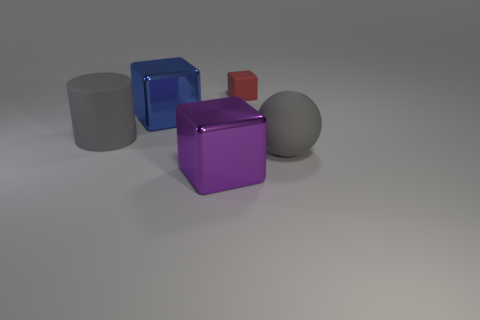Subtract all red blocks. How many blocks are left? 2 Add 4 gray rubber cylinders. How many objects exist? 9 Subtract all gray blocks. Subtract all gray balls. How many blocks are left? 3 Subtract all cubes. How many objects are left? 2 Add 5 gray matte cylinders. How many gray matte cylinders are left? 6 Add 4 tiny blue matte spheres. How many tiny blue matte spheres exist? 4 Subtract 0 brown cylinders. How many objects are left? 5 Subtract all blocks. Subtract all gray balls. How many objects are left? 1 